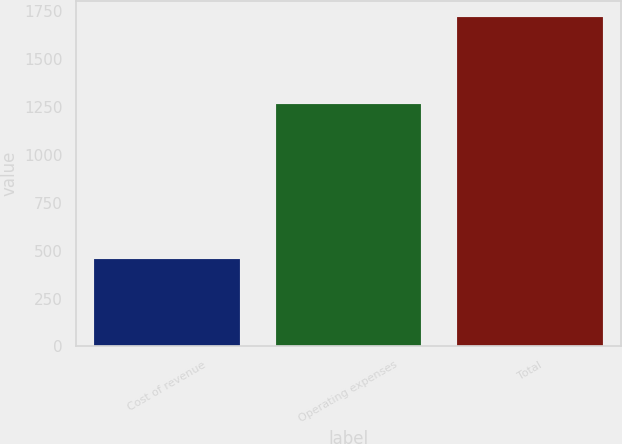Convert chart. <chart><loc_0><loc_0><loc_500><loc_500><bar_chart><fcel>Cost of revenue<fcel>Operating expenses<fcel>Total<nl><fcel>453.6<fcel>1262.2<fcel>1715.8<nl></chart> 